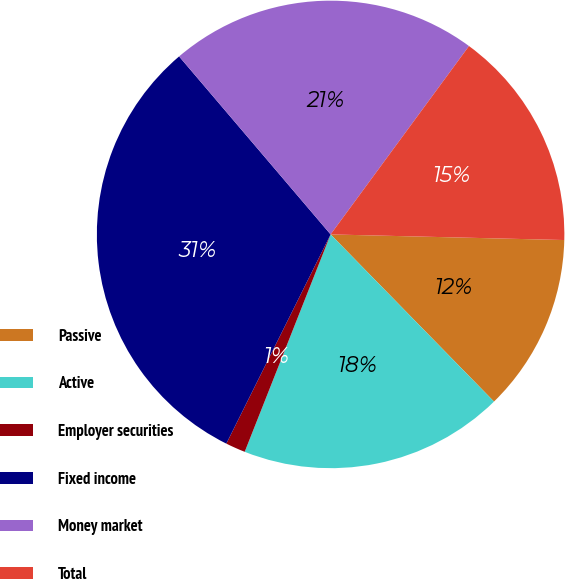Convert chart to OTSL. <chart><loc_0><loc_0><loc_500><loc_500><pie_chart><fcel>Passive<fcel>Active<fcel>Employer securities<fcel>Fixed income<fcel>Money market<fcel>Total<nl><fcel>12.3%<fcel>18.31%<fcel>1.37%<fcel>31.42%<fcel>21.31%<fcel>15.3%<nl></chart> 